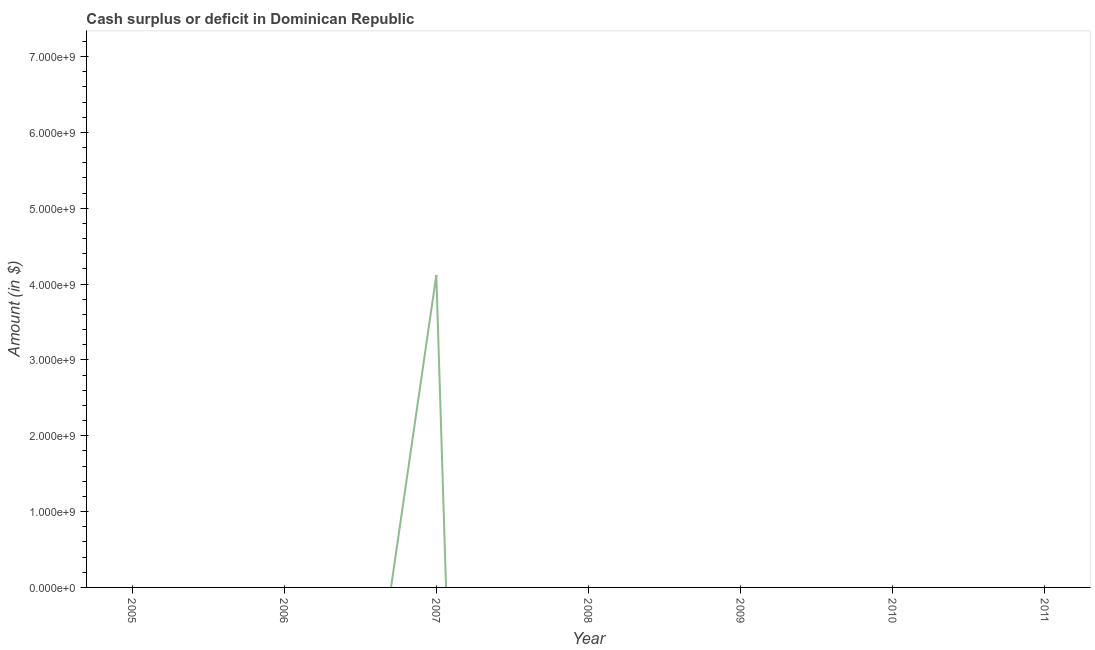What is the cash surplus or deficit in 2005?
Make the answer very short. 0. Across all years, what is the maximum cash surplus or deficit?
Ensure brevity in your answer.  4.12e+09. What is the sum of the cash surplus or deficit?
Provide a succinct answer. 4.12e+09. What is the average cash surplus or deficit per year?
Your answer should be compact. 5.88e+08. In how many years, is the cash surplus or deficit greater than 5800000000 $?
Ensure brevity in your answer.  0. What is the difference between the highest and the lowest cash surplus or deficit?
Your answer should be compact. 4.12e+09. In how many years, is the cash surplus or deficit greater than the average cash surplus or deficit taken over all years?
Your response must be concise. 1. How many lines are there?
Ensure brevity in your answer.  1. Are the values on the major ticks of Y-axis written in scientific E-notation?
Offer a terse response. Yes. Does the graph contain any zero values?
Your answer should be compact. Yes. What is the title of the graph?
Make the answer very short. Cash surplus or deficit in Dominican Republic. What is the label or title of the Y-axis?
Provide a short and direct response. Amount (in $). What is the Amount (in $) of 2007?
Provide a succinct answer. 4.12e+09. What is the Amount (in $) in 2008?
Offer a terse response. 0. What is the Amount (in $) in 2009?
Keep it short and to the point. 0. 